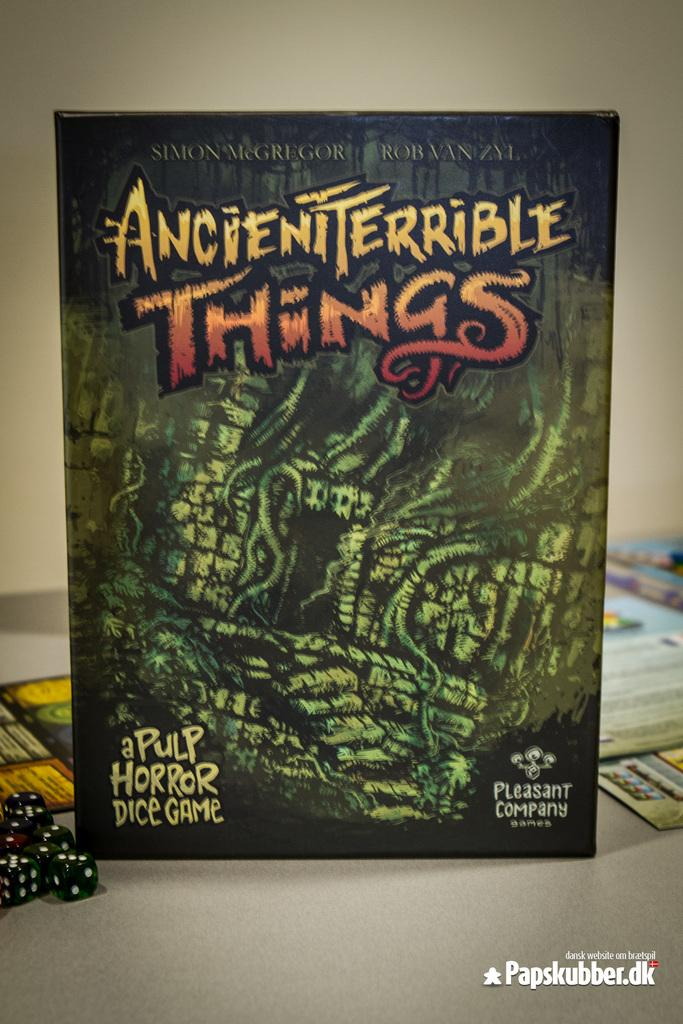<image>
Summarize the visual content of the image. The green and scary looking box cover for the Ancient Terrible Things dice game. 